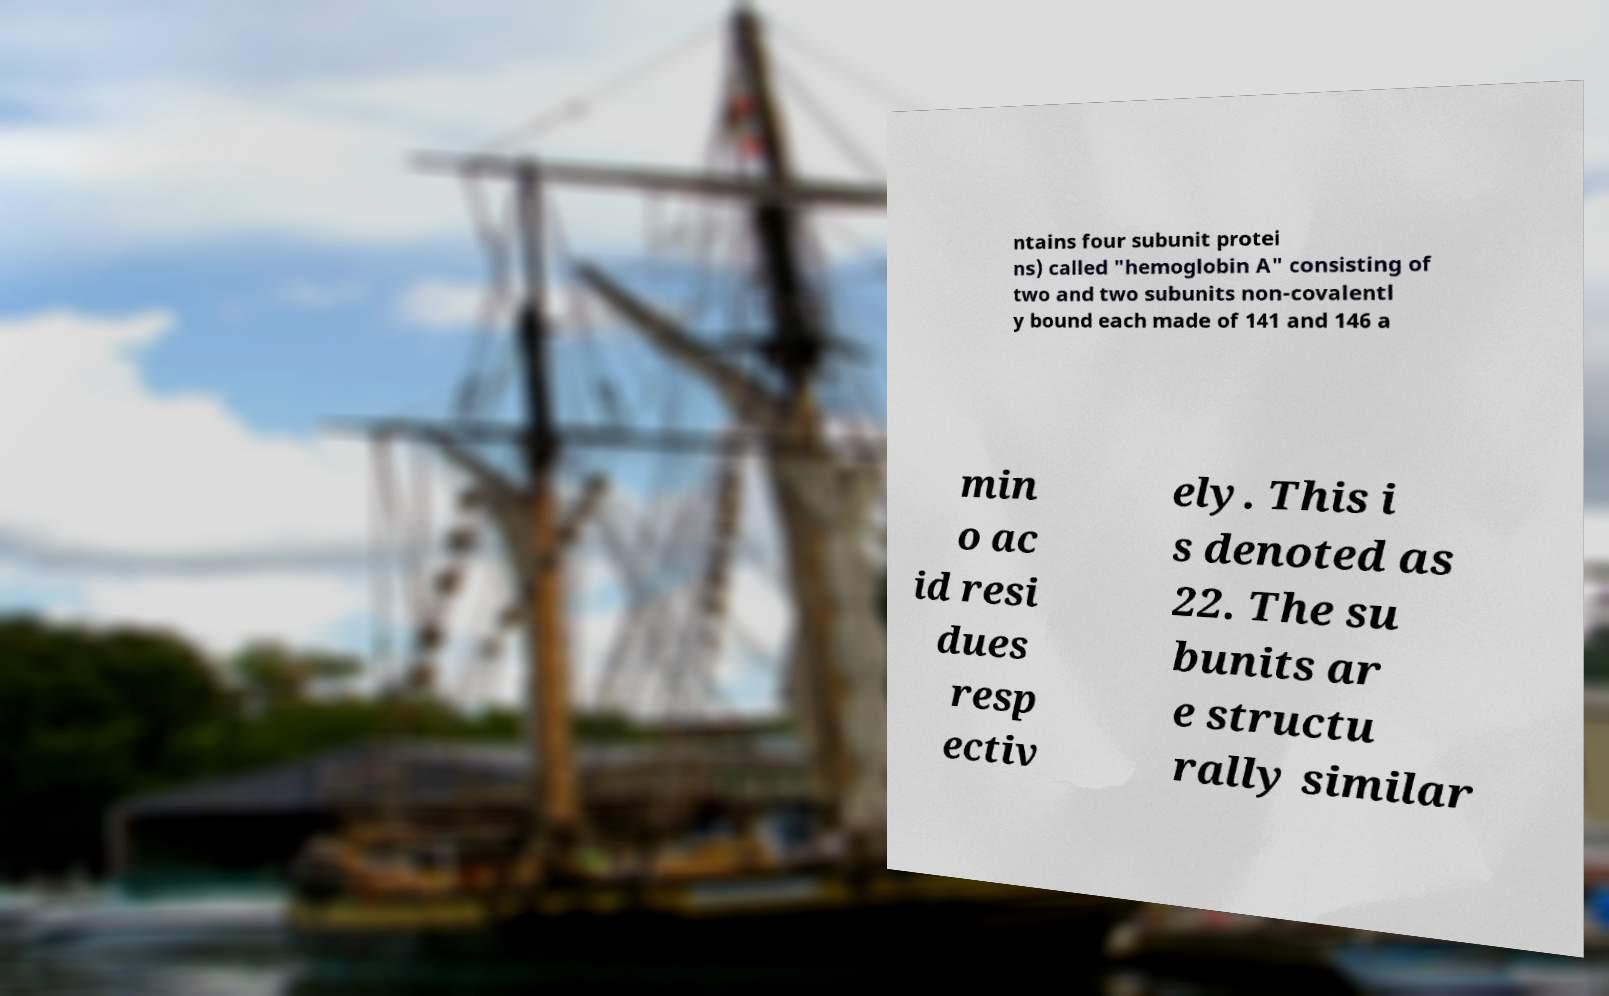Can you accurately transcribe the text from the provided image for me? ntains four subunit protei ns) called "hemoglobin A" consisting of two and two subunits non-covalentl y bound each made of 141 and 146 a min o ac id resi dues resp ectiv ely. This i s denoted as 22. The su bunits ar e structu rally similar 